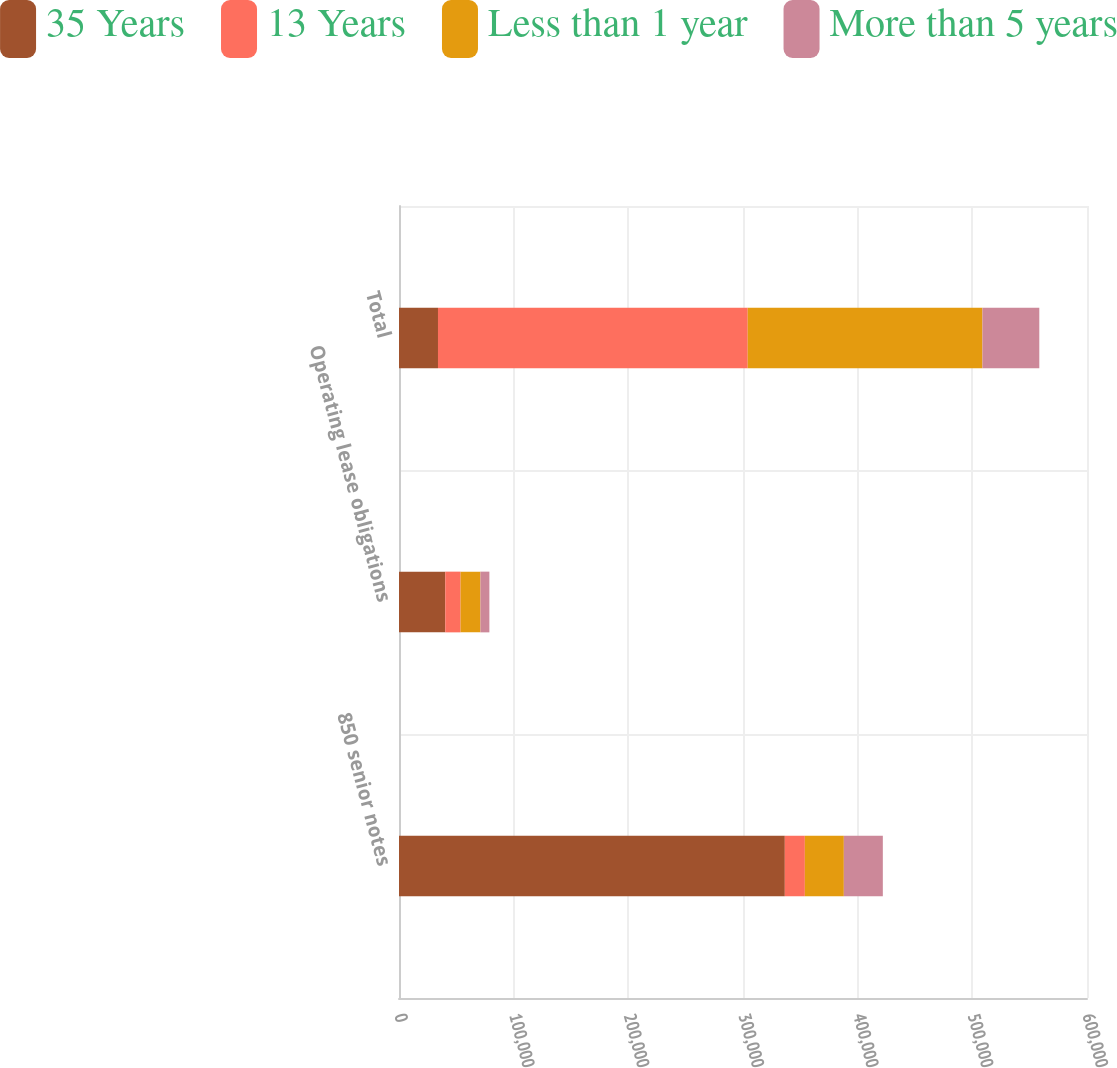<chart> <loc_0><loc_0><loc_500><loc_500><stacked_bar_chart><ecel><fcel>850 senior notes<fcel>Operating lease obligations<fcel>Total<nl><fcel>35 Years<fcel>336472<fcel>40347<fcel>34000<nl><fcel>13 Years<fcel>17472<fcel>13313<fcel>270121<nl><fcel>Less than 1 year<fcel>34000<fcel>17354<fcel>204708<nl><fcel>More than 5 years<fcel>34000<fcel>7812<fcel>49577<nl></chart> 